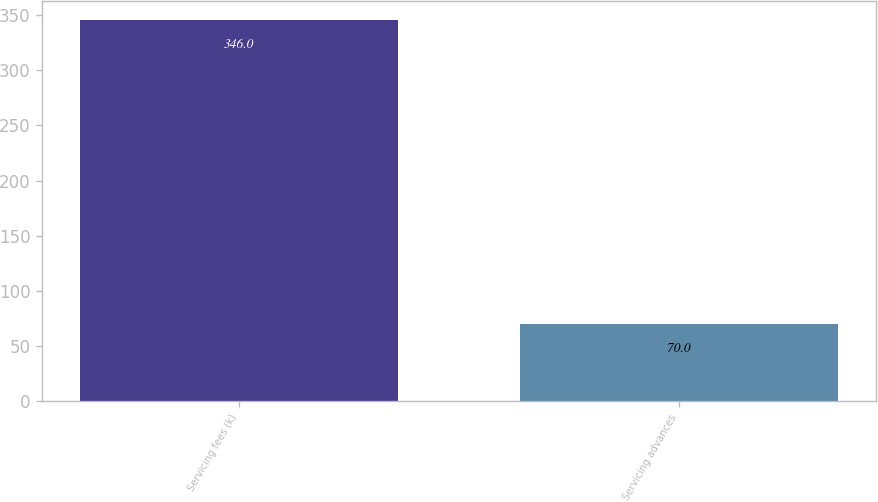Convert chart to OTSL. <chart><loc_0><loc_0><loc_500><loc_500><bar_chart><fcel>Servicing fees (k)<fcel>Servicing advances<nl><fcel>346<fcel>70<nl></chart> 